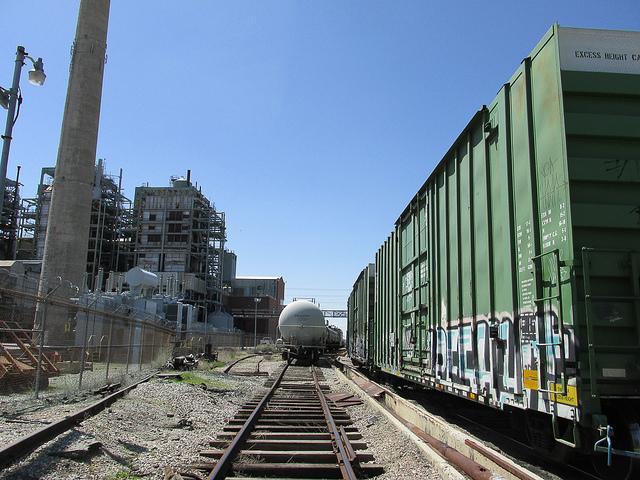What fuel does the train run on?
Concise answer only. Gas. What color is the box car?
Keep it brief. Green. What is the white tanker running on?
Give a very brief answer. Tracks. Is a train coming?
Write a very short answer. No. 